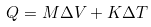<formula> <loc_0><loc_0><loc_500><loc_500>Q = M \Delta V + K \Delta T</formula> 